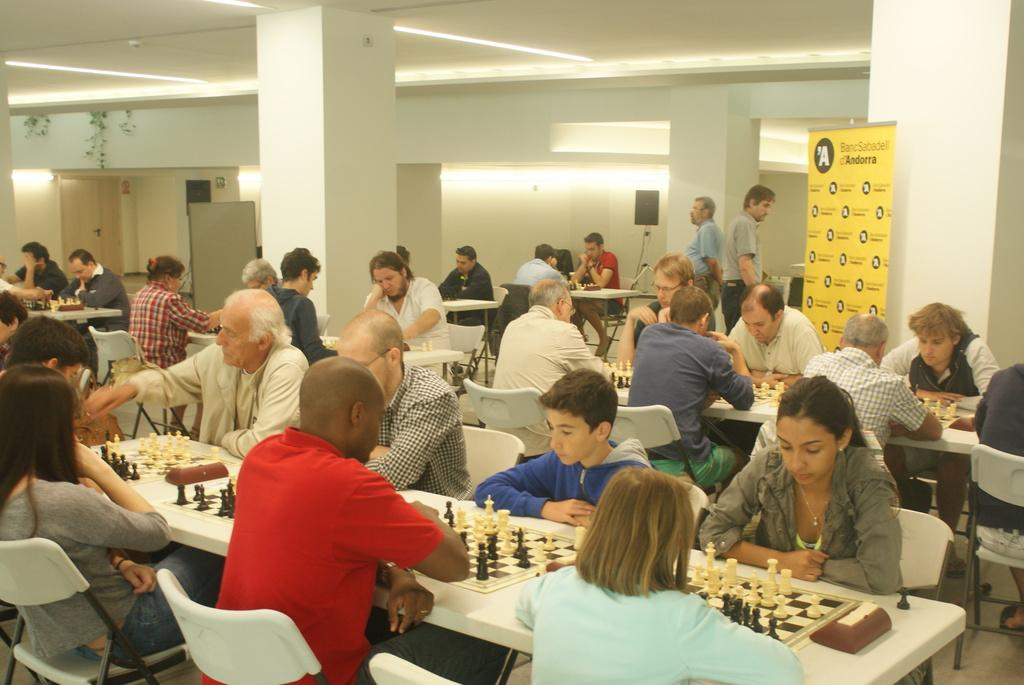What are the people in the image doing? The people in the image are sitting. What is on the table in the image? There is a chess board and coins on the table. Are there any fairies flying around the chess board in the image? No, there are no fairies present in the image. What type of event is taking place in the image? The image does not depict a specific event; it simply shows people sitting at a table with a chess board and coins. 